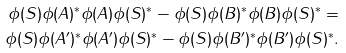Convert formula to latex. <formula><loc_0><loc_0><loc_500><loc_500>\phi ( S ) \phi ( A ) ^ { * } \phi ( A ) \phi ( S ) ^ { * } - \phi ( S ) \phi ( B ) ^ { * } \phi ( B ) \phi ( S ) ^ { * } = \\ \phi ( S ) \phi ( A ^ { \prime } ) ^ { * } \phi ( A ^ { \prime } ) \phi ( S ) ^ { * } - \phi ( S ) \phi ( B ^ { \prime } ) ^ { * } \phi ( B ^ { \prime } ) \phi ( S ) ^ { * } .</formula> 